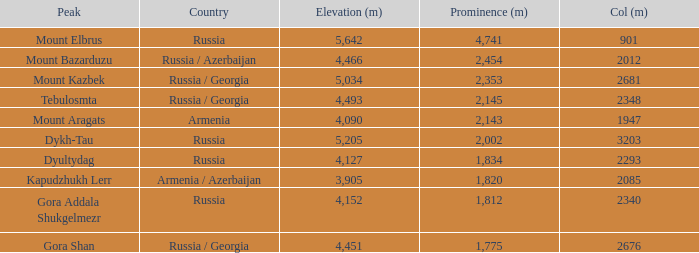What is the height in meters of the peak that has a prominence greater than 2,143 meters and a col of 2,012 meters? 4466.0. 